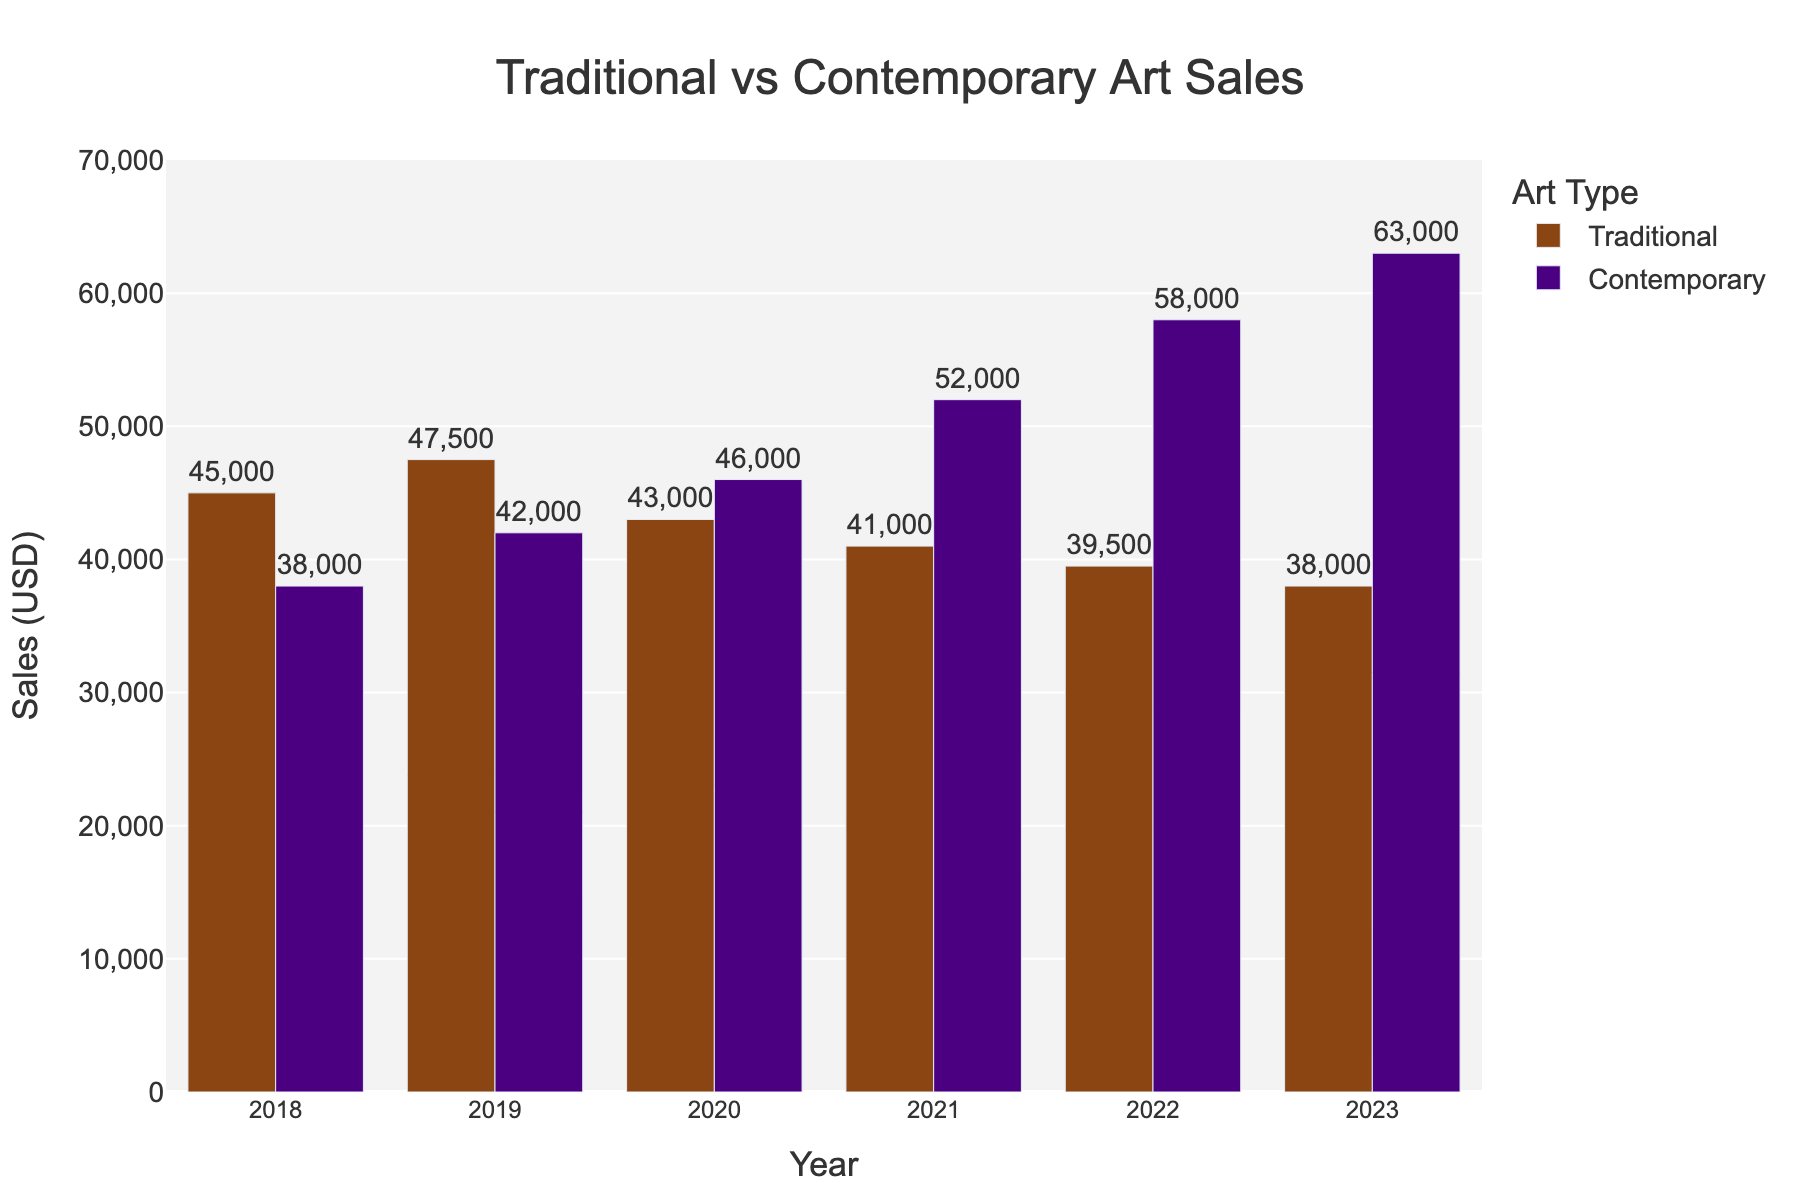What is the overall trend in sales for traditional artworks from 2018 to 2023? By visual inspection of the bars representing traditional artworks, the height decreases from 45000 in 2018 to 38000 in 2023, indicating a downward trend.
Answer: Downward In which year did contemporary artworks surpass traditional artworks in sales? By comparing the heights of the bars for traditional and contemporary artworks, contemporary artworks first surpass traditional artworks in 2020 (46000 vs. 43000).
Answer: 2020 What is the difference in sales between traditional and contemporary artworks in 2022? The sales for traditional artworks in 2022 are 39500, and for contemporary artworks, it's 58000. The difference is calculated as 58000 - 39500.
Answer: 18500 On average, how much did sales for traditional artworks decrease each year from 2018 to 2023? Sales in 2018 were 45000, and in 2023 were 38000. The difference is 45000 - 38000 = 7000. Over 5 years, the average decrease per year is 7000 / 5.
Answer: 1400 Which type of artwork had the highest increase in sales between consecutive years, and in which year did this occur? By inspecting the bar heights, the most significant increase is in contemporary artworks from 2021 to 2022, rising from 52000 to 58000, which is an increase of 6000.
Answer: Contemporary, 2021-2022 How many years did traditional artworks have higher sales compared to contemporary artworks? By comparing the heights of the bars for each year, traditional artworks had higher sales in 2018 and 2019.
Answer: 2 What is the total sales amount for contemporary artworks over the six years? Summing the sales for contemporary artworks from 2018 to 2023: 38000 + 42000 + 46000 + 52000 + 58000 + 63000 = 299000.
Answer: 299000 Which year saw the largest drop in sales for traditional artworks compared to the previous year? By comparing the differences year by year, the largest drop is from 2019 to 2020: 47500 - 43000 = 4500.
Answer: 2020 What is the percentage increase in sales for contemporary artworks from 2018 to 2023? The sales increased from 38000 in 2018 to 63000 in 2023. The percentage increase is calculated as ((63000 - 38000) / 38000) * 100.
Answer: 65.8% What is the combined sales for both traditional and contemporary artworks in 2021? Adding the sales for both types in 2021: 41000 (Traditional) + 52000 (Contemporary) = 93000.
Answer: 93000 